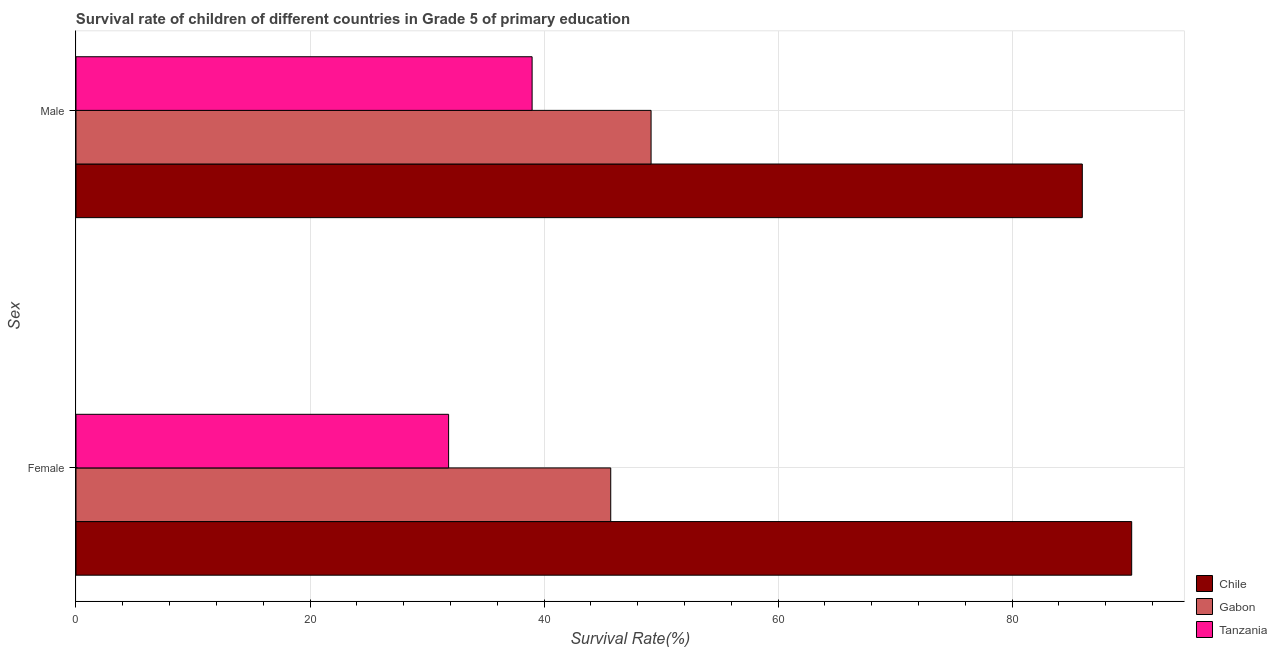How many different coloured bars are there?
Make the answer very short. 3. Are the number of bars on each tick of the Y-axis equal?
Ensure brevity in your answer.  Yes. What is the label of the 2nd group of bars from the top?
Your answer should be very brief. Female. What is the survival rate of male students in primary education in Gabon?
Offer a terse response. 49.15. Across all countries, what is the maximum survival rate of female students in primary education?
Offer a terse response. 90.23. Across all countries, what is the minimum survival rate of female students in primary education?
Give a very brief answer. 31.85. In which country was the survival rate of female students in primary education minimum?
Your answer should be compact. Tanzania. What is the total survival rate of male students in primary education in the graph?
Ensure brevity in your answer.  174.14. What is the difference between the survival rate of male students in primary education in Tanzania and that in Chile?
Your answer should be compact. -47.02. What is the difference between the survival rate of female students in primary education in Gabon and the survival rate of male students in primary education in Tanzania?
Your answer should be compact. 6.72. What is the average survival rate of male students in primary education per country?
Give a very brief answer. 58.05. What is the difference between the survival rate of male students in primary education and survival rate of female students in primary education in Gabon?
Your response must be concise. 3.45. In how many countries, is the survival rate of female students in primary education greater than 88 %?
Make the answer very short. 1. What is the ratio of the survival rate of male students in primary education in Tanzania to that in Chile?
Offer a terse response. 0.45. Is the survival rate of female students in primary education in Tanzania less than that in Chile?
Make the answer very short. Yes. What does the 3rd bar from the top in Female represents?
Your answer should be compact. Chile. What does the 3rd bar from the bottom in Female represents?
Offer a terse response. Tanzania. Are all the bars in the graph horizontal?
Your response must be concise. Yes. How many countries are there in the graph?
Your response must be concise. 3. What is the difference between two consecutive major ticks on the X-axis?
Give a very brief answer. 20. Where does the legend appear in the graph?
Your answer should be very brief. Bottom right. How many legend labels are there?
Keep it short and to the point. 3. How are the legend labels stacked?
Provide a succinct answer. Vertical. What is the title of the graph?
Offer a very short reply. Survival rate of children of different countries in Grade 5 of primary education. What is the label or title of the X-axis?
Offer a very short reply. Survival Rate(%). What is the label or title of the Y-axis?
Give a very brief answer. Sex. What is the Survival Rate(%) of Chile in Female?
Your answer should be very brief. 90.23. What is the Survival Rate(%) of Gabon in Female?
Offer a very short reply. 45.7. What is the Survival Rate(%) of Tanzania in Female?
Your response must be concise. 31.85. What is the Survival Rate(%) of Chile in Male?
Make the answer very short. 86.01. What is the Survival Rate(%) of Gabon in Male?
Provide a succinct answer. 49.15. What is the Survival Rate(%) in Tanzania in Male?
Provide a succinct answer. 38.98. Across all Sex, what is the maximum Survival Rate(%) of Chile?
Ensure brevity in your answer.  90.23. Across all Sex, what is the maximum Survival Rate(%) in Gabon?
Keep it short and to the point. 49.15. Across all Sex, what is the maximum Survival Rate(%) in Tanzania?
Provide a succinct answer. 38.98. Across all Sex, what is the minimum Survival Rate(%) in Chile?
Ensure brevity in your answer.  86.01. Across all Sex, what is the minimum Survival Rate(%) of Gabon?
Make the answer very short. 45.7. Across all Sex, what is the minimum Survival Rate(%) in Tanzania?
Make the answer very short. 31.85. What is the total Survival Rate(%) in Chile in the graph?
Your answer should be very brief. 176.24. What is the total Survival Rate(%) in Gabon in the graph?
Your answer should be very brief. 94.86. What is the total Survival Rate(%) of Tanzania in the graph?
Your answer should be very brief. 70.83. What is the difference between the Survival Rate(%) in Chile in Female and that in Male?
Your response must be concise. 4.22. What is the difference between the Survival Rate(%) in Gabon in Female and that in Male?
Your answer should be compact. -3.45. What is the difference between the Survival Rate(%) of Tanzania in Female and that in Male?
Keep it short and to the point. -7.14. What is the difference between the Survival Rate(%) of Chile in Female and the Survival Rate(%) of Gabon in Male?
Make the answer very short. 41.08. What is the difference between the Survival Rate(%) in Chile in Female and the Survival Rate(%) in Tanzania in Male?
Ensure brevity in your answer.  51.24. What is the difference between the Survival Rate(%) in Gabon in Female and the Survival Rate(%) in Tanzania in Male?
Keep it short and to the point. 6.72. What is the average Survival Rate(%) of Chile per Sex?
Your answer should be compact. 88.12. What is the average Survival Rate(%) of Gabon per Sex?
Keep it short and to the point. 47.43. What is the average Survival Rate(%) in Tanzania per Sex?
Provide a succinct answer. 35.42. What is the difference between the Survival Rate(%) of Chile and Survival Rate(%) of Gabon in Female?
Give a very brief answer. 44.52. What is the difference between the Survival Rate(%) in Chile and Survival Rate(%) in Tanzania in Female?
Provide a short and direct response. 58.38. What is the difference between the Survival Rate(%) of Gabon and Survival Rate(%) of Tanzania in Female?
Provide a short and direct response. 13.86. What is the difference between the Survival Rate(%) in Chile and Survival Rate(%) in Gabon in Male?
Your response must be concise. 36.86. What is the difference between the Survival Rate(%) of Chile and Survival Rate(%) of Tanzania in Male?
Offer a terse response. 47.02. What is the difference between the Survival Rate(%) in Gabon and Survival Rate(%) in Tanzania in Male?
Provide a short and direct response. 10.17. What is the ratio of the Survival Rate(%) in Chile in Female to that in Male?
Provide a short and direct response. 1.05. What is the ratio of the Survival Rate(%) in Gabon in Female to that in Male?
Give a very brief answer. 0.93. What is the ratio of the Survival Rate(%) of Tanzania in Female to that in Male?
Offer a terse response. 0.82. What is the difference between the highest and the second highest Survival Rate(%) in Chile?
Provide a succinct answer. 4.22. What is the difference between the highest and the second highest Survival Rate(%) of Gabon?
Make the answer very short. 3.45. What is the difference between the highest and the second highest Survival Rate(%) of Tanzania?
Give a very brief answer. 7.14. What is the difference between the highest and the lowest Survival Rate(%) in Chile?
Offer a very short reply. 4.22. What is the difference between the highest and the lowest Survival Rate(%) of Gabon?
Provide a succinct answer. 3.45. What is the difference between the highest and the lowest Survival Rate(%) in Tanzania?
Offer a very short reply. 7.14. 